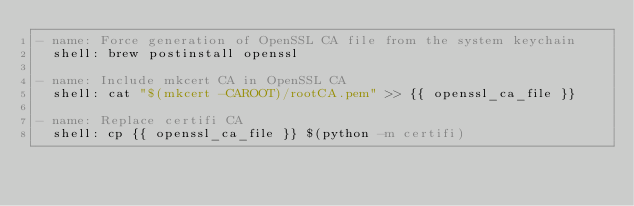<code> <loc_0><loc_0><loc_500><loc_500><_YAML_>- name: Force generation of OpenSSL CA file from the system keychain
  shell: brew postinstall openssl

- name: Include mkcert CA in OpenSSL CA
  shell: cat "$(mkcert -CAROOT)/rootCA.pem" >> {{ openssl_ca_file }}

- name: Replace certifi CA 
  shell: cp {{ openssl_ca_file }} $(python -m certifi)

  </code> 